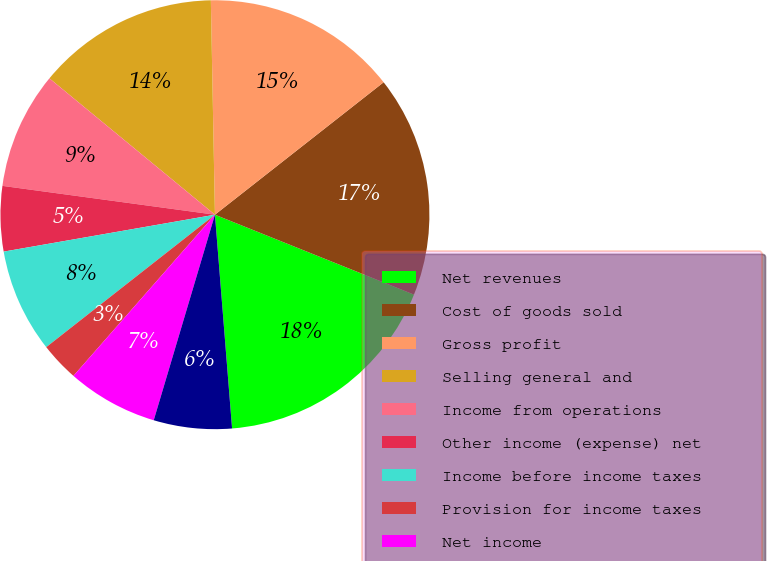Convert chart. <chart><loc_0><loc_0><loc_500><loc_500><pie_chart><fcel>Net revenues<fcel>Cost of goods sold<fcel>Gross profit<fcel>Selling general and<fcel>Income from operations<fcel>Other income (expense) net<fcel>Income before income taxes<fcel>Provision for income taxes<fcel>Net income<fcel>Net income available to common<nl><fcel>17.65%<fcel>16.67%<fcel>14.71%<fcel>13.73%<fcel>8.82%<fcel>4.9%<fcel>7.84%<fcel>2.94%<fcel>6.86%<fcel>5.88%<nl></chart> 